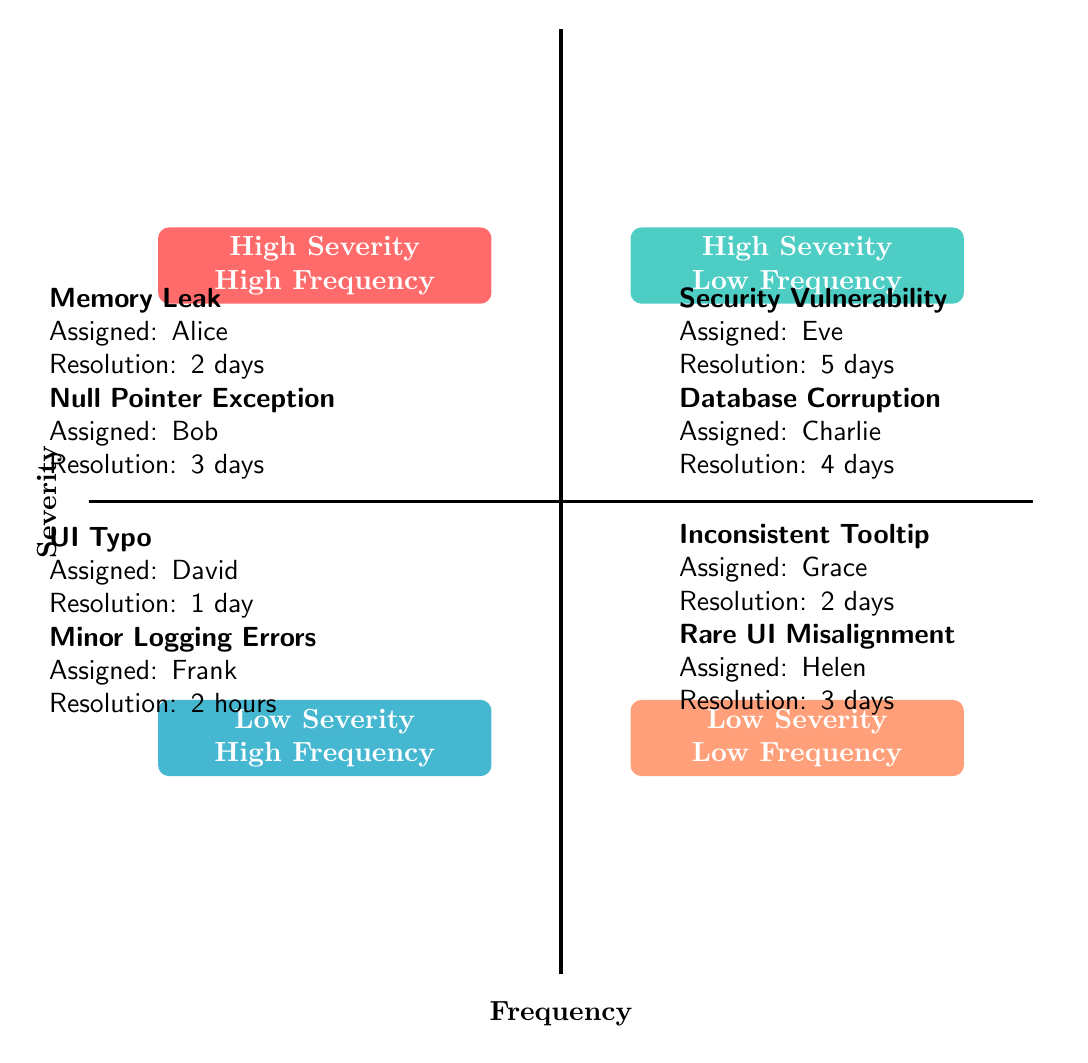What are the two bugs in the High Severity - High Frequency quadrant? The High Severity - High Frequency quadrant contains two bugs: "Memory Leak in Data Processing" and "Null Pointer Exception in API." These were identified based on the quadrant label and the bugs listed within it.
Answer: Memory Leak in Data Processing, Null Pointer Exception in API Who was assigned to resolve the Critical Security Vulnerability? The Critical Security Vulnerability, located in the High Severity - Low Frequency quadrant, was last assigned to "Eve," as noted in the information provided for that quadrant.
Answer: Eve How many bugs are classified as Low Severity - High Frequency? The Low Severity - High Frequency quadrant has two bugs listed: "Typo in User Interface" and "Minor Logging Errors," which indicates that there are two bugs in this classification.
Answer: 2 What is the average resolution time for the bug reported by the UX Team? The bug reported by the UX Team, "Inconsistent Tooltip Text," is located in the Low Severity - Low Frequency quadrant, with an average resolution time of "2 days" as detailed in the specifics of that bug.
Answer: 2 days Which bug has the longest resolution time among all quadrants? Among all the bugs listed, the "Critical Security Vulnerability" from the High Severity - Low Frequency quadrant has the longest resolution time of "5 days," which is the maximum time mentioned in the bug resolution details.
Answer: 5 days Which quadrant contains bugs assigned to both the Backend Team and the Frontend Team? The High Severity - High Frequency quadrant includes the bug assigned to the Backend Team ("Memory Leak in Data Processing"), while the Low Severity - High Frequency quadrant includes the bug assigned to the Frontend Team ("Typo in User Interface"). This identifies that bugs from both teams are represented in different quadrants.
Answer: High Severity - High Frequency, Low Severity - High Frequency What is the average resolution time for bugs assigned to the Frontend Team? The Frontend Team is responsible for two bugs: "Typo in User Interface" with a resolution time of "1 day" and "Rare UI Misalignment" with "3 days." The average of these two times is (1 + 3)/2 = 2 days.
Answer: 2 days Which quadrant has the fewest number of bugs assigned? The quadrants with fewer bugs are the High Severity - Low Frequency and Low Severity - Low Frequency quadrants. Each quadrant contains two bugs, making both of them equally least populated in terms of assigned bugs.
Answer: High Severity - Low Frequency, Low Severity - Low Frequency 